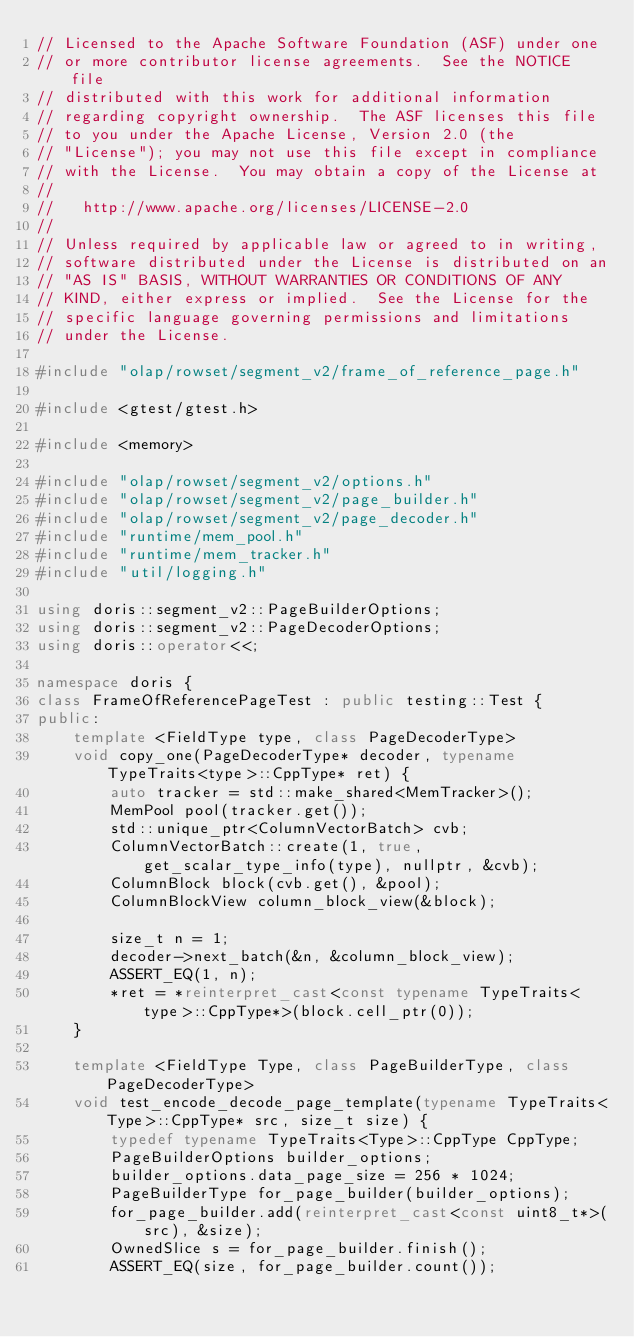Convert code to text. <code><loc_0><loc_0><loc_500><loc_500><_C++_>// Licensed to the Apache Software Foundation (ASF) under one
// or more contributor license agreements.  See the NOTICE file
// distributed with this work for additional information
// regarding copyright ownership.  The ASF licenses this file
// to you under the Apache License, Version 2.0 (the
// "License"); you may not use this file except in compliance
// with the License.  You may obtain a copy of the License at
//
//   http://www.apache.org/licenses/LICENSE-2.0
//
// Unless required by applicable law or agreed to in writing,
// software distributed under the License is distributed on an
// "AS IS" BASIS, WITHOUT WARRANTIES OR CONDITIONS OF ANY
// KIND, either express or implied.  See the License for the
// specific language governing permissions and limitations
// under the License.

#include "olap/rowset/segment_v2/frame_of_reference_page.h"

#include <gtest/gtest.h>

#include <memory>

#include "olap/rowset/segment_v2/options.h"
#include "olap/rowset/segment_v2/page_builder.h"
#include "olap/rowset/segment_v2/page_decoder.h"
#include "runtime/mem_pool.h"
#include "runtime/mem_tracker.h"
#include "util/logging.h"

using doris::segment_v2::PageBuilderOptions;
using doris::segment_v2::PageDecoderOptions;
using doris::operator<<;

namespace doris {
class FrameOfReferencePageTest : public testing::Test {
public:
    template <FieldType type, class PageDecoderType>
    void copy_one(PageDecoderType* decoder, typename TypeTraits<type>::CppType* ret) {
        auto tracker = std::make_shared<MemTracker>();
        MemPool pool(tracker.get());
        std::unique_ptr<ColumnVectorBatch> cvb;
        ColumnVectorBatch::create(1, true, get_scalar_type_info(type), nullptr, &cvb);
        ColumnBlock block(cvb.get(), &pool);
        ColumnBlockView column_block_view(&block);

        size_t n = 1;
        decoder->next_batch(&n, &column_block_view);
        ASSERT_EQ(1, n);
        *ret = *reinterpret_cast<const typename TypeTraits<type>::CppType*>(block.cell_ptr(0));
    }

    template <FieldType Type, class PageBuilderType, class PageDecoderType>
    void test_encode_decode_page_template(typename TypeTraits<Type>::CppType* src, size_t size) {
        typedef typename TypeTraits<Type>::CppType CppType;
        PageBuilderOptions builder_options;
        builder_options.data_page_size = 256 * 1024;
        PageBuilderType for_page_builder(builder_options);
        for_page_builder.add(reinterpret_cast<const uint8_t*>(src), &size);
        OwnedSlice s = for_page_builder.finish();
        ASSERT_EQ(size, for_page_builder.count());</code> 